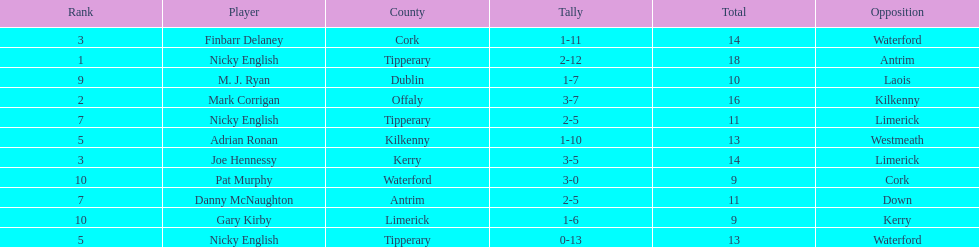Joe hennessy and finbarr delaney both scored how many points? 14. 